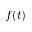<formula> <loc_0><loc_0><loc_500><loc_500>f ( t )</formula> 